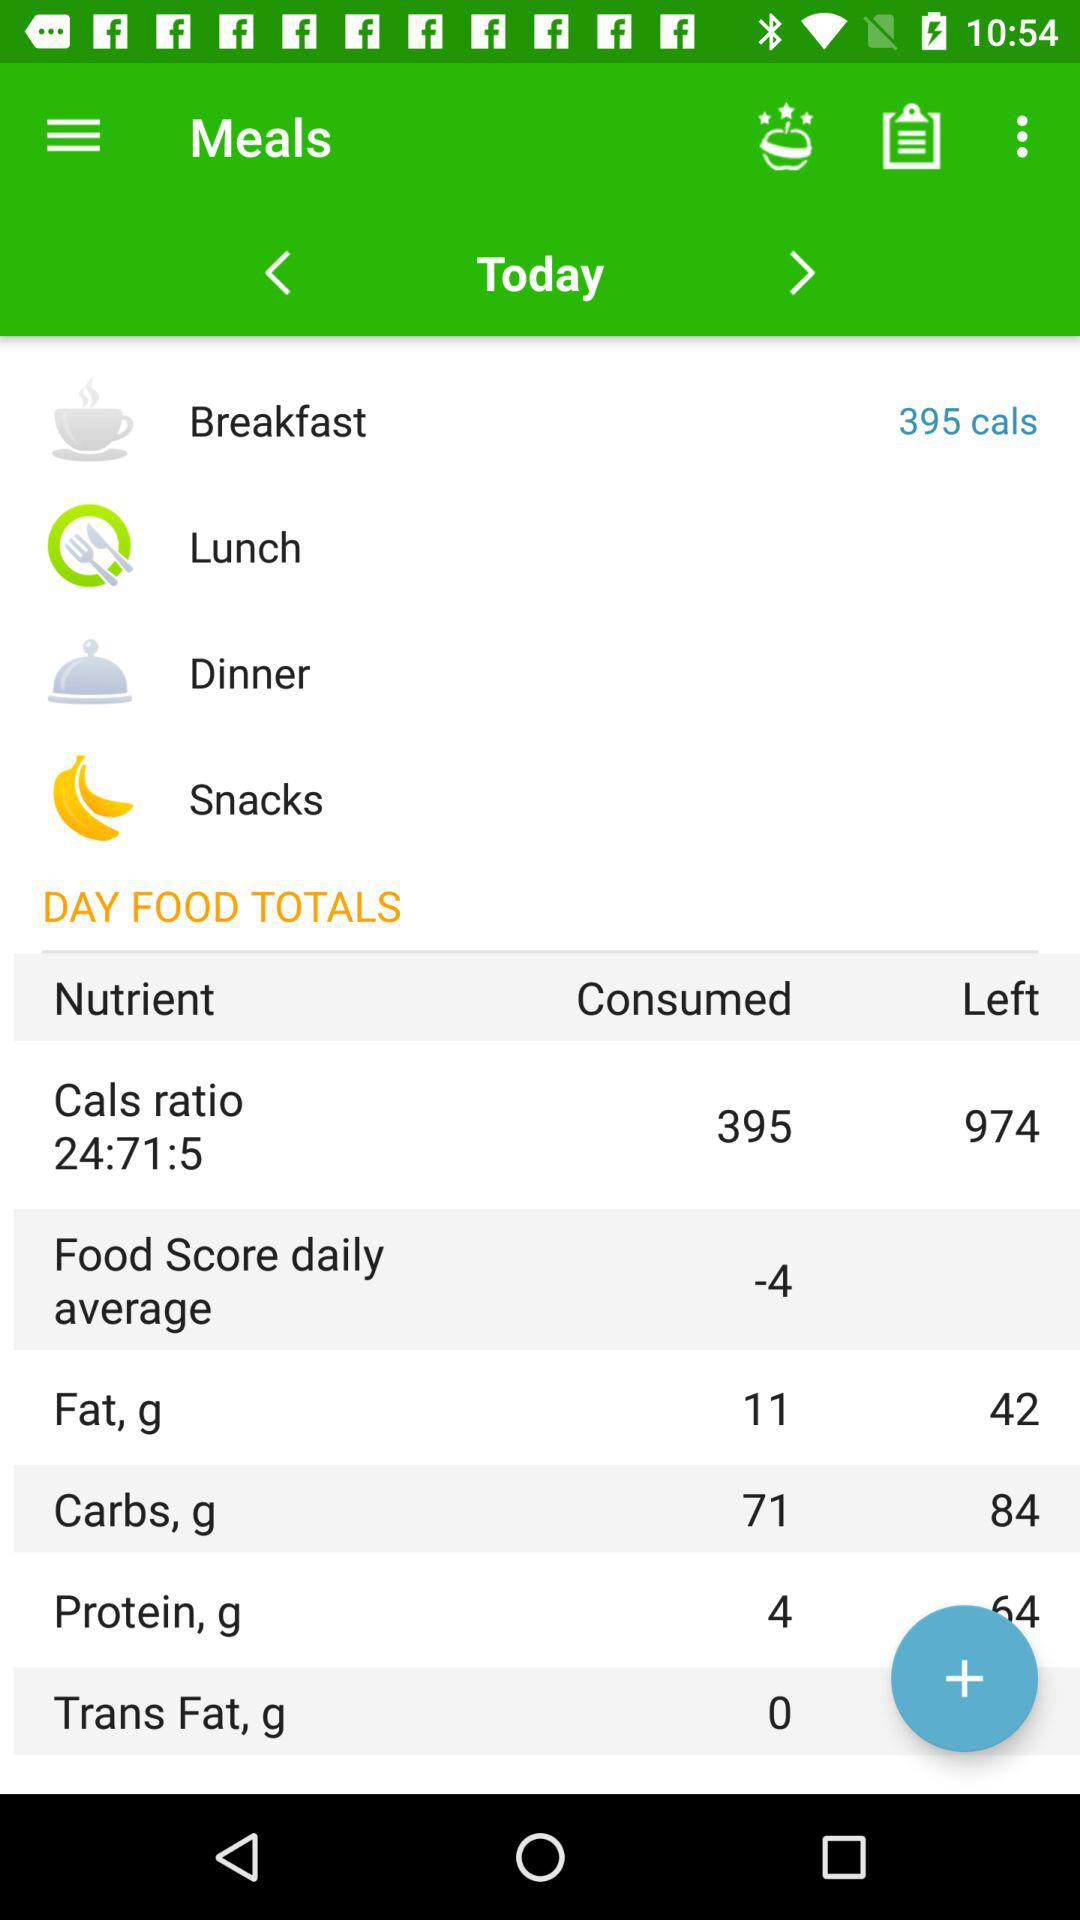How many grams of fat are consumed? The fat consumed is 11 grams. 